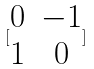Convert formula to latex. <formula><loc_0><loc_0><loc_500><loc_500>[ \begin{matrix} 0 & - 1 \\ 1 & 0 \end{matrix} ]</formula> 